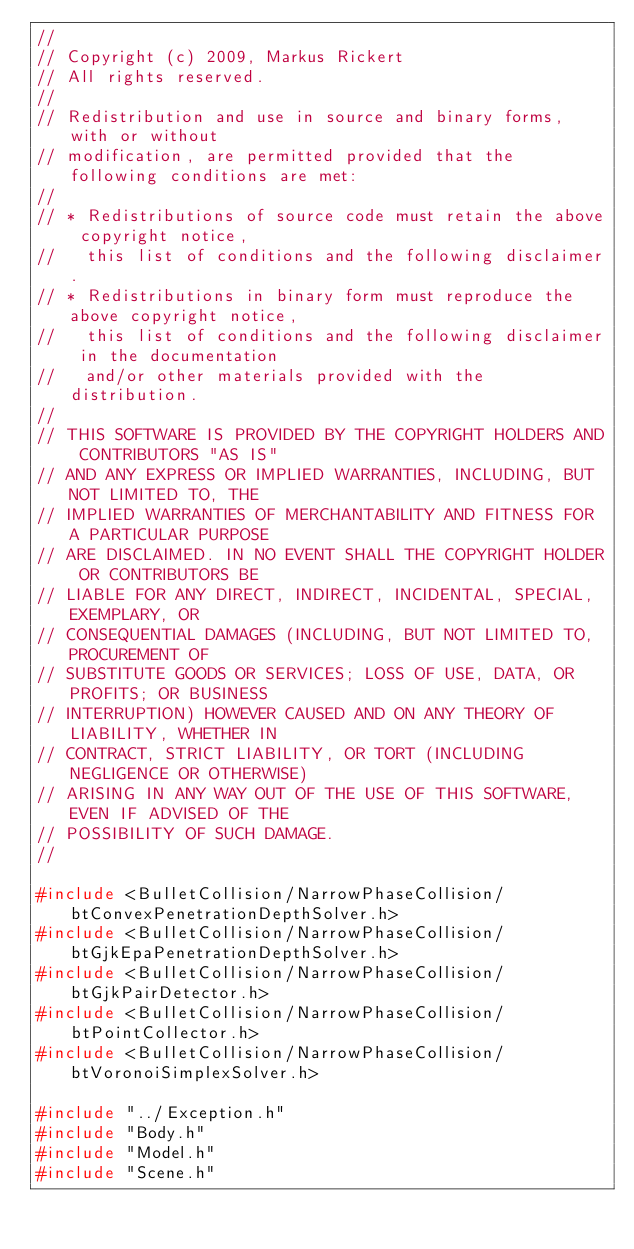<code> <loc_0><loc_0><loc_500><loc_500><_C++_>//
// Copyright (c) 2009, Markus Rickert
// All rights reserved.
//
// Redistribution and use in source and binary forms, with or without
// modification, are permitted provided that the following conditions are met:
//
// * Redistributions of source code must retain the above copyright notice,
//   this list of conditions and the following disclaimer.
// * Redistributions in binary form must reproduce the above copyright notice,
//   this list of conditions and the following disclaimer in the documentation
//   and/or other materials provided with the distribution.
//
// THIS SOFTWARE IS PROVIDED BY THE COPYRIGHT HOLDERS AND CONTRIBUTORS "AS IS"
// AND ANY EXPRESS OR IMPLIED WARRANTIES, INCLUDING, BUT NOT LIMITED TO, THE
// IMPLIED WARRANTIES OF MERCHANTABILITY AND FITNESS FOR A PARTICULAR PURPOSE
// ARE DISCLAIMED. IN NO EVENT SHALL THE COPYRIGHT HOLDER OR CONTRIBUTORS BE
// LIABLE FOR ANY DIRECT, INDIRECT, INCIDENTAL, SPECIAL, EXEMPLARY, OR
// CONSEQUENTIAL DAMAGES (INCLUDING, BUT NOT LIMITED TO, PROCUREMENT OF
// SUBSTITUTE GOODS OR SERVICES; LOSS OF USE, DATA, OR PROFITS; OR BUSINESS
// INTERRUPTION) HOWEVER CAUSED AND ON ANY THEORY OF LIABILITY, WHETHER IN
// CONTRACT, STRICT LIABILITY, OR TORT (INCLUDING NEGLIGENCE OR OTHERWISE)
// ARISING IN ANY WAY OUT OF THE USE OF THIS SOFTWARE, EVEN IF ADVISED OF THE
// POSSIBILITY OF SUCH DAMAGE.
//

#include <BulletCollision/NarrowPhaseCollision/btConvexPenetrationDepthSolver.h>
#include <BulletCollision/NarrowPhaseCollision/btGjkEpaPenetrationDepthSolver.h>
#include <BulletCollision/NarrowPhaseCollision/btGjkPairDetector.h>
#include <BulletCollision/NarrowPhaseCollision/btPointCollector.h>
#include <BulletCollision/NarrowPhaseCollision/btVoronoiSimplexSolver.h>

#include "../Exception.h"
#include "Body.h"
#include "Model.h"
#include "Scene.h"</code> 